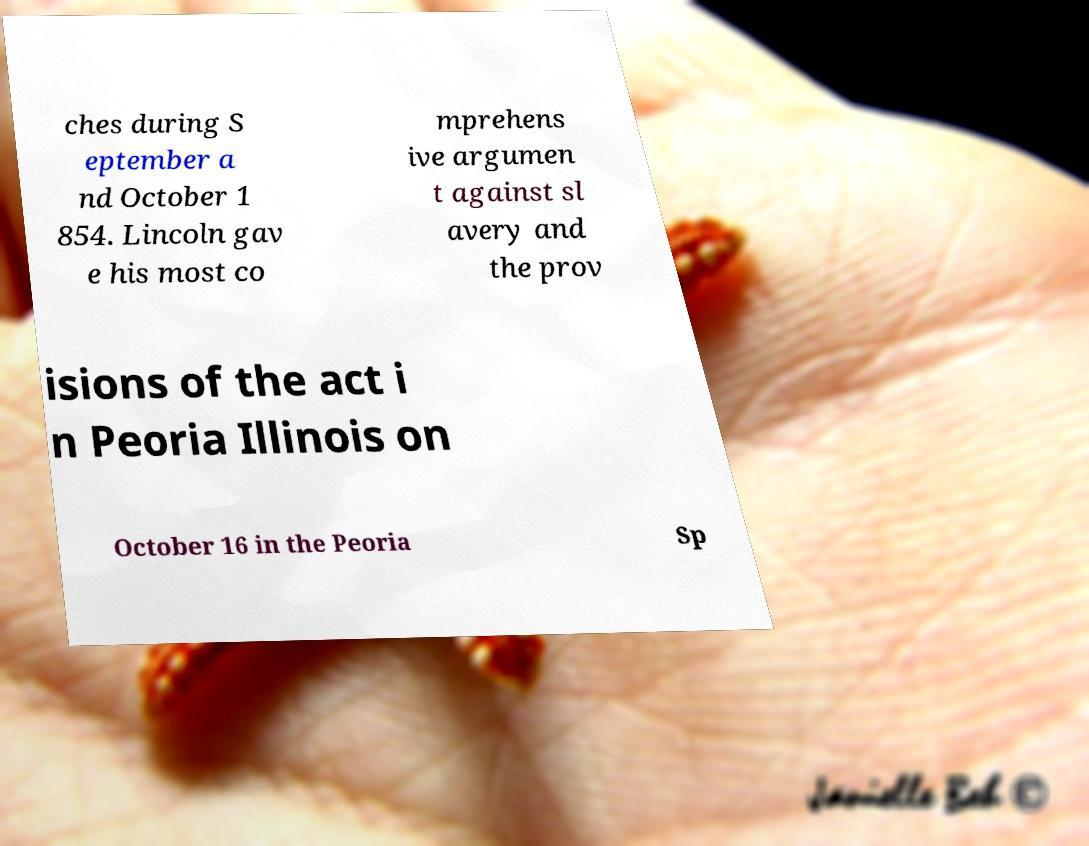Can you read and provide the text displayed in the image?This photo seems to have some interesting text. Can you extract and type it out for me? ches during S eptember a nd October 1 854. Lincoln gav e his most co mprehens ive argumen t against sl avery and the prov isions of the act i n Peoria Illinois on October 16 in the Peoria Sp 